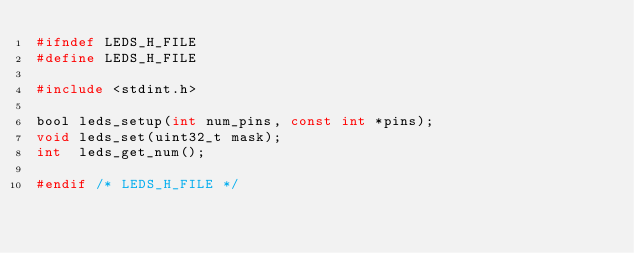Convert code to text. <code><loc_0><loc_0><loc_500><loc_500><_C_>#ifndef LEDS_H_FILE
#define LEDS_H_FILE

#include <stdint.h>

bool leds_setup(int num_pins, const int *pins);
void leds_set(uint32_t mask);
int  leds_get_num();

#endif /* LEDS_H_FILE */
</code> 